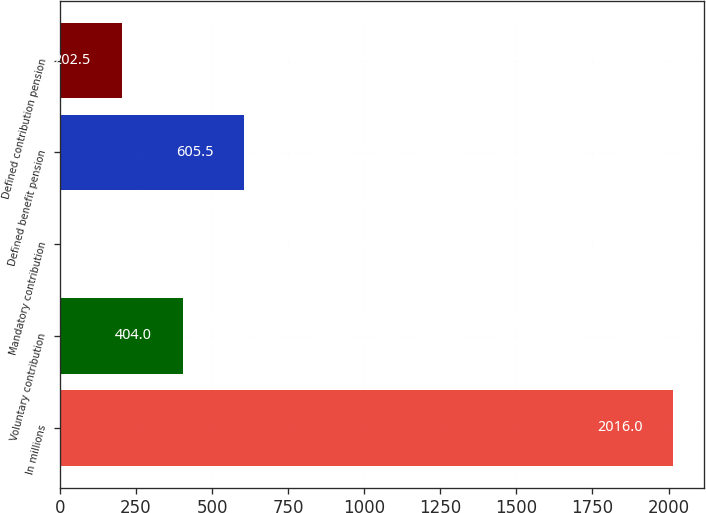<chart> <loc_0><loc_0><loc_500><loc_500><bar_chart><fcel>In millions<fcel>Voluntary contribution<fcel>Mandatory contribution<fcel>Defined benefit pension<fcel>Defined contribution pension<nl><fcel>2016<fcel>404<fcel>1<fcel>605.5<fcel>202.5<nl></chart> 